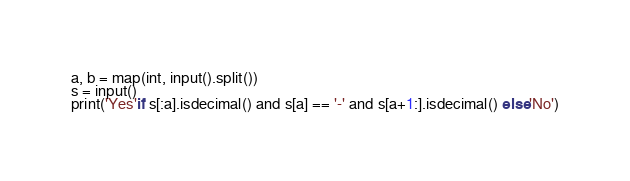Convert code to text. <code><loc_0><loc_0><loc_500><loc_500><_Python_>a, b = map(int, input().split())
s = input()
print('Yes'if s[:a].isdecimal() and s[a] == '-' and s[a+1:].isdecimal() else'No')</code> 